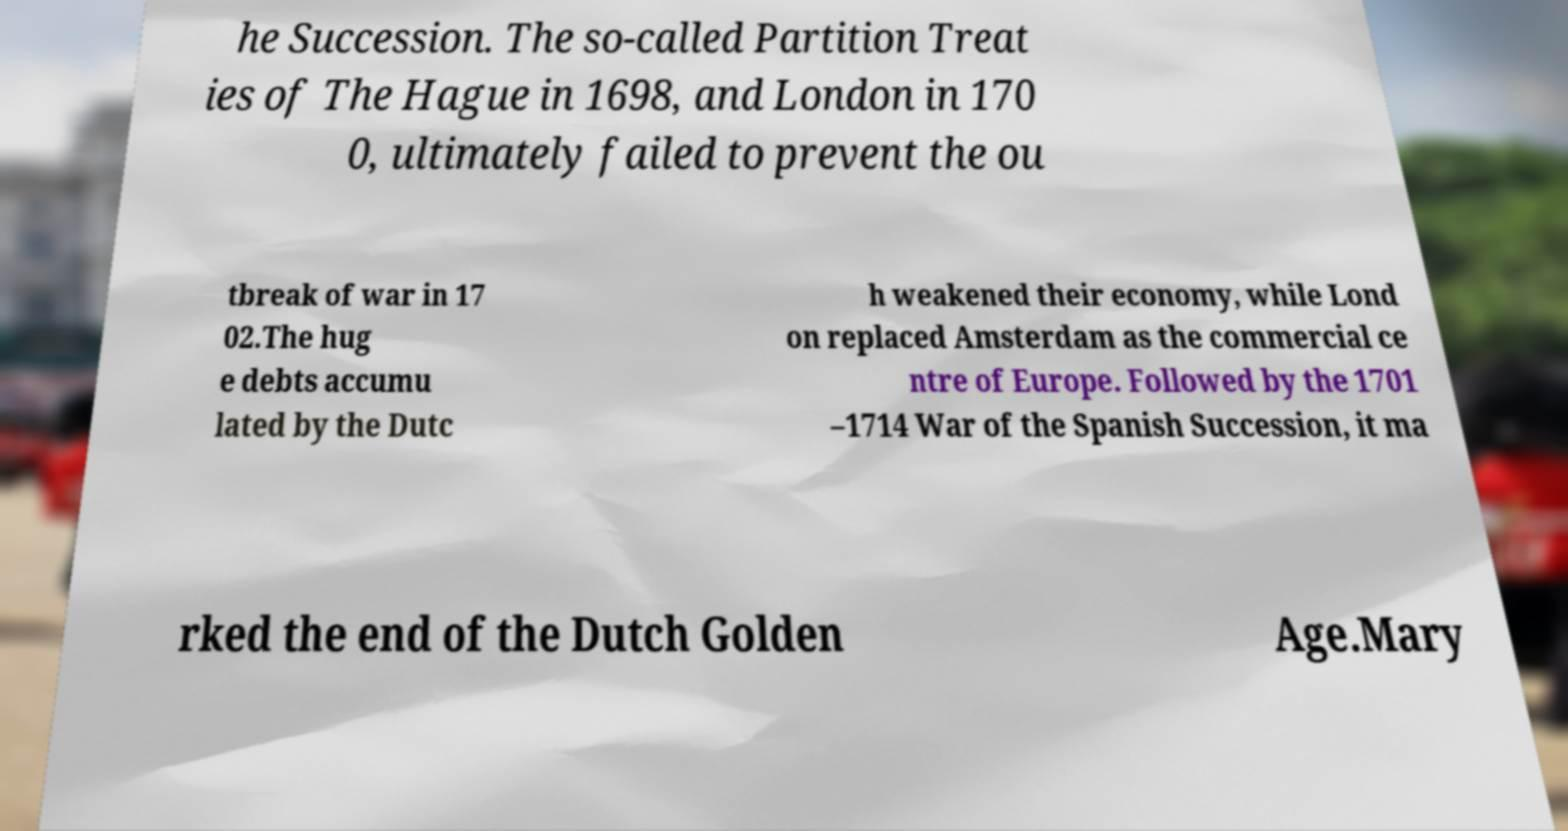Please identify and transcribe the text found in this image. he Succession. The so-called Partition Treat ies of The Hague in 1698, and London in 170 0, ultimately failed to prevent the ou tbreak of war in 17 02.The hug e debts accumu lated by the Dutc h weakened their economy, while Lond on replaced Amsterdam as the commercial ce ntre of Europe. Followed by the 1701 –1714 War of the Spanish Succession, it ma rked the end of the Dutch Golden Age.Mary 